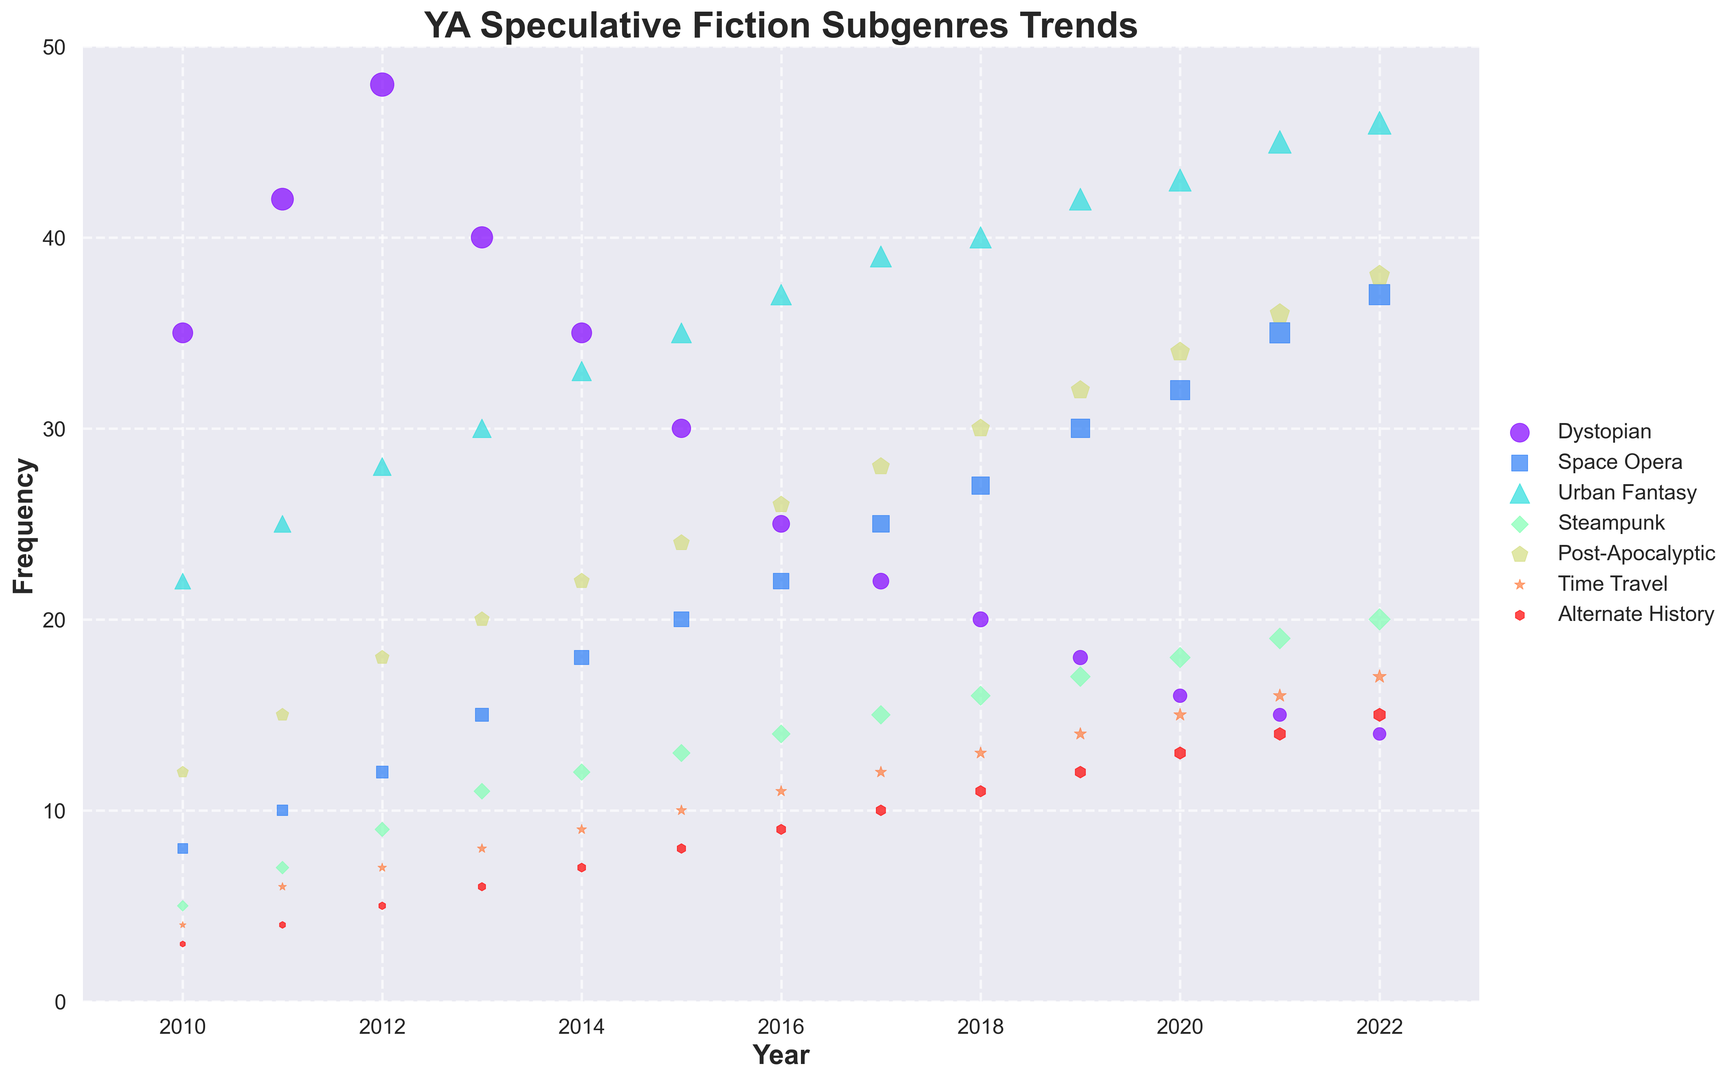What was the most frequently occurring subgenre in 2010? Look at the scatter plot for the year 2010, identify the subgenre with the largest bubble. The largest bubble represents the highest frequency.
Answer: Dystopian Which subgenre shows the highest increase in frequency from 2010 to 2022? Calculate the difference in frequencies for each subgenre between 2022 and 2010, and identify the subgenre with the highest positive change.
Answer: Urban Fantasy Did any subgenre show a constant increase in frequency every year from 2010 to 2022? Inspect the scatter plot for each subgenre to see if the bubble size increases consistently year after year.
Answer: Urban Fantasy Which subgenre had the lowest frequency in 2022? Identify the smallest bubble in the year 2022 for all subgenres in the scatter plot.
Answer: Dystopian In which years did the subgenre 'Space Opera' have frequency equal to or greater than 'Dystopian'? For each year, compare the sizes of the bubbles for 'Space Opera' and 'Dystopian,' starting from 2010 to 2022, and note the years where 'Space Opera' is greater than or equal to 'Dystopian'.
Answer: 2019, 2020, 2021, 2022 What is the total frequency for 'Steampunk' across all years? Sum the frequencies of 'Steampunk' for each year from 2010 to 2022. Include each year's value in the calculation.
Answer: 179 Did the frequency of any subgenre peak before 2013 and then decline? If yes, which one? Examine the scatter plot for each subgenre to see if there is a peak before 2013 followed by a decline.
Answer: Dystopian How many subgenres had a frequency of exactly 20 in any year? Count the number of subgenres for which a bubble appears at the frequency of 20 in any year between 2010 and 2022.
Answer: 2 (Space Opera in 2015, Steampunk in 2022) Between 'Post-Apocalyptic' and 'Time Travel,' which subgenre has seen a more consistent increase in frequency over the years? Compare the trends of 'Post-Apocalyptic' and 'Time Travel' by observing their bubble size trends from 2010 to 2022.
Answer: Post-Apocalyptic 